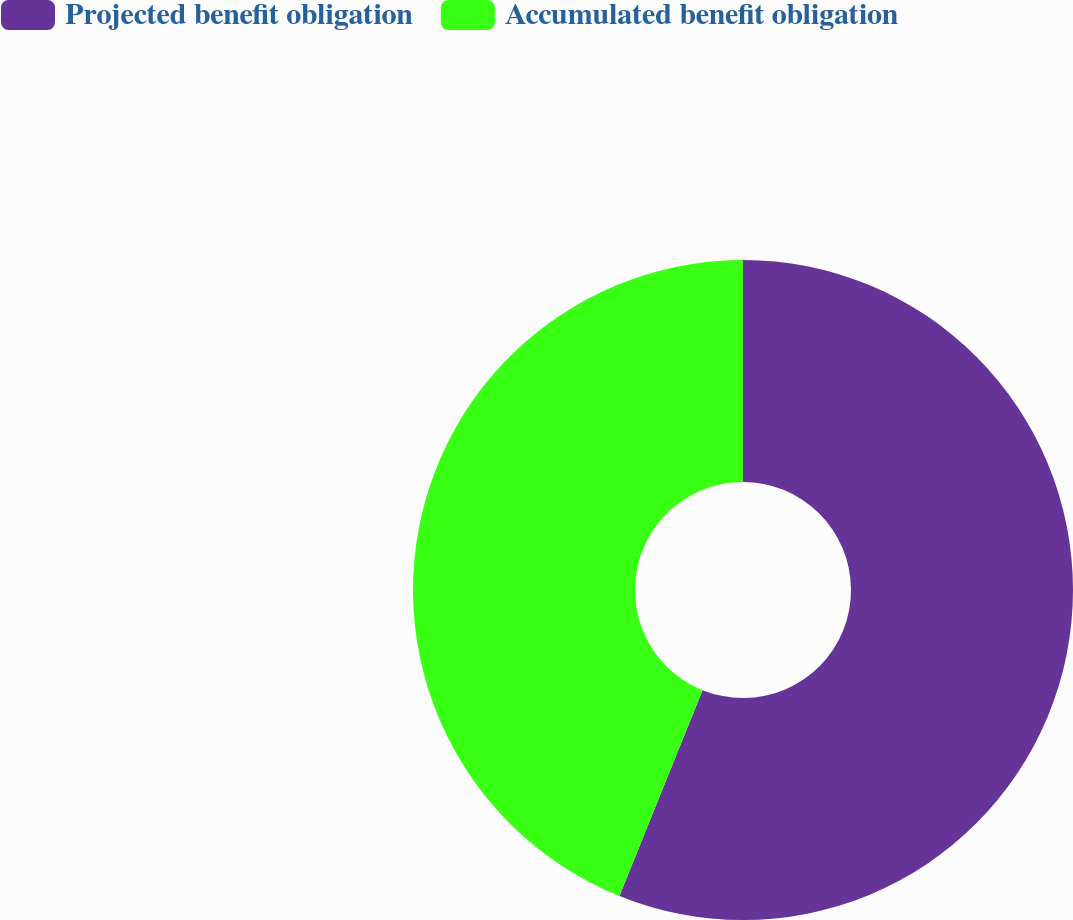Convert chart to OTSL. <chart><loc_0><loc_0><loc_500><loc_500><pie_chart><fcel>Projected benefit obligation<fcel>Accumulated benefit obligation<nl><fcel>56.11%<fcel>43.89%<nl></chart> 